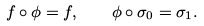<formula> <loc_0><loc_0><loc_500><loc_500>f \circ \phi = f , \quad \phi \circ \sigma _ { 0 } = \sigma _ { 1 } .</formula> 